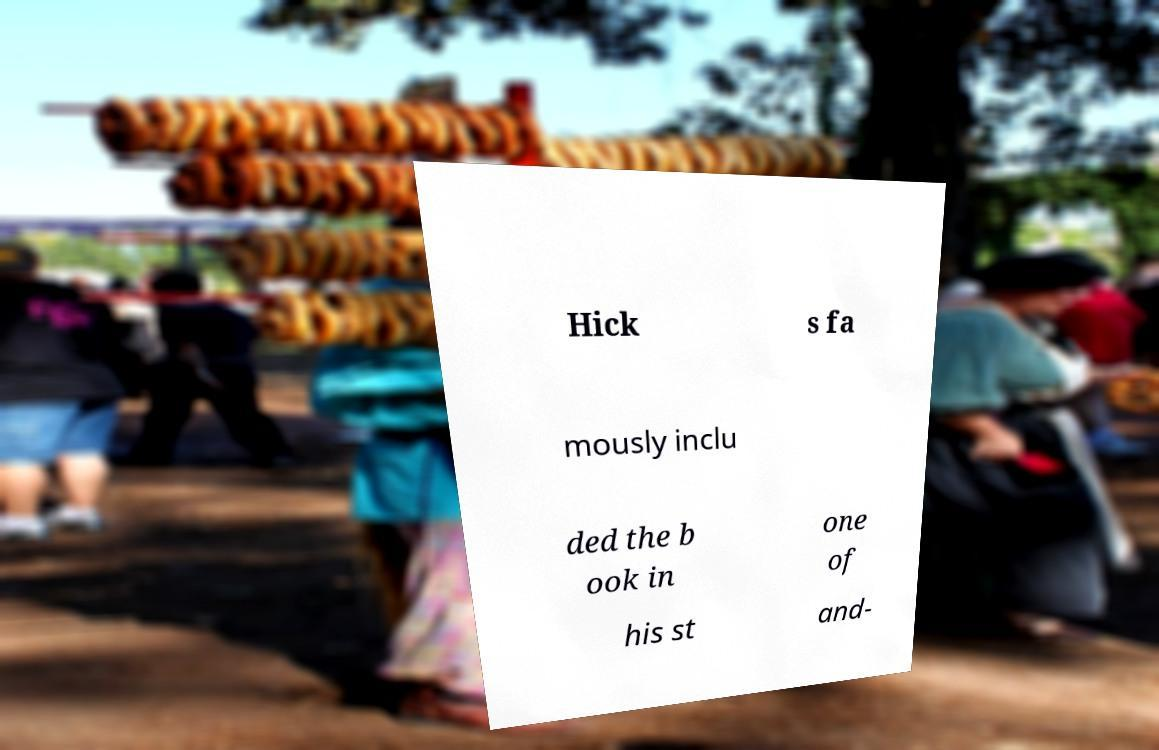What messages or text are displayed in this image? I need them in a readable, typed format. Hick s fa mously inclu ded the b ook in one of his st and- 